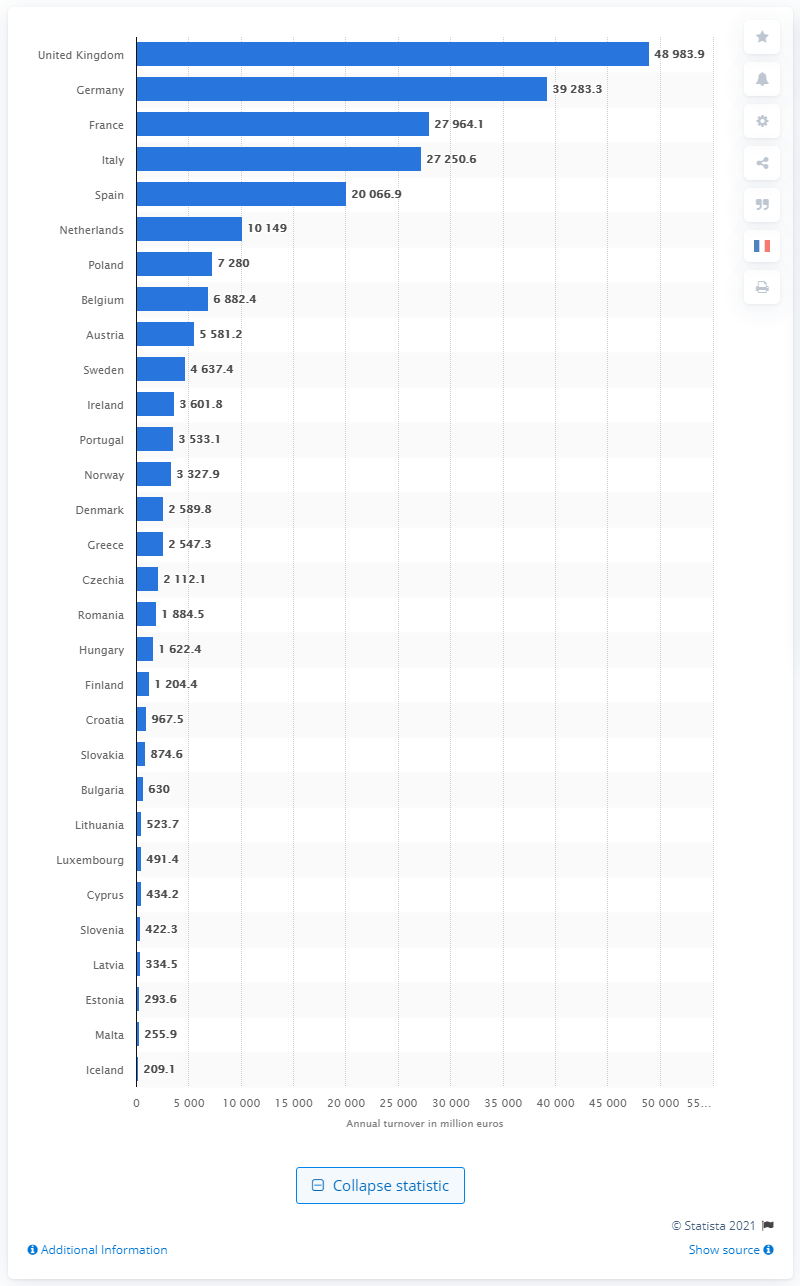List a handful of essential elements in this visual. In 2018, the annual turnover from retail sales of clothing in the UK was approximately 48,983.9 million pounds. 